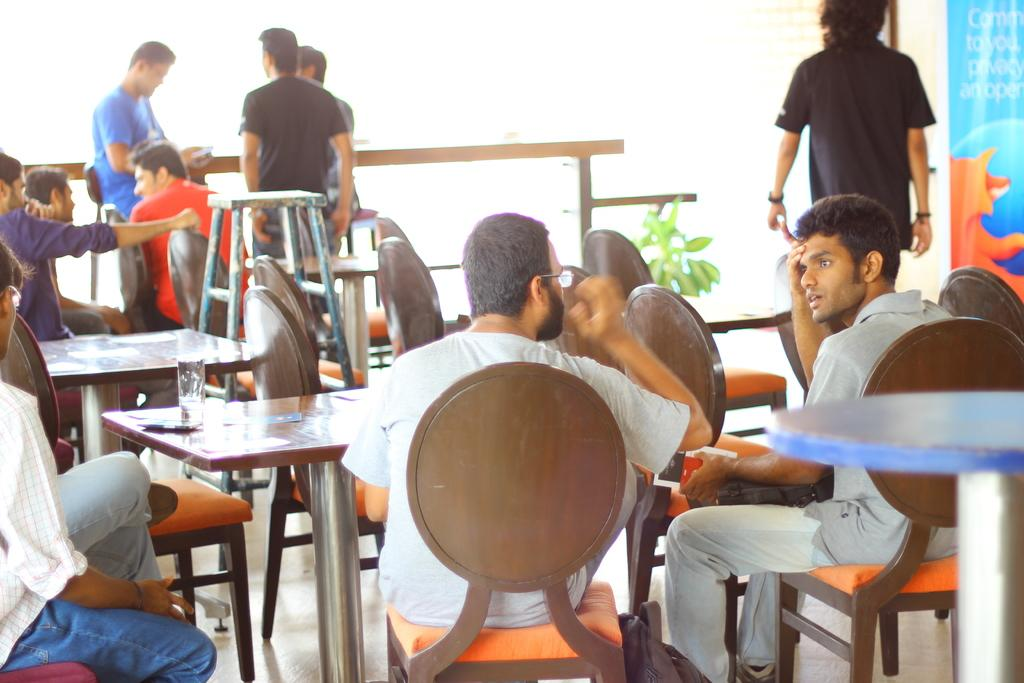What is the composition of the group in the image? There is a group of people in the image, with some sitting and some standing. Can you describe the positions of the people in the group? Some people in the group are sitting, while others are standing. What type of ray is visible in the image? There is no ray present in the image; it features a group of people. What muscle is being exercised by the people in the image? The image does not show any specific muscles being exercised; it simply depicts people sitting and standing. 